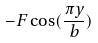<formula> <loc_0><loc_0><loc_500><loc_500>- F \cos ( \frac { \pi y } { b } )</formula> 